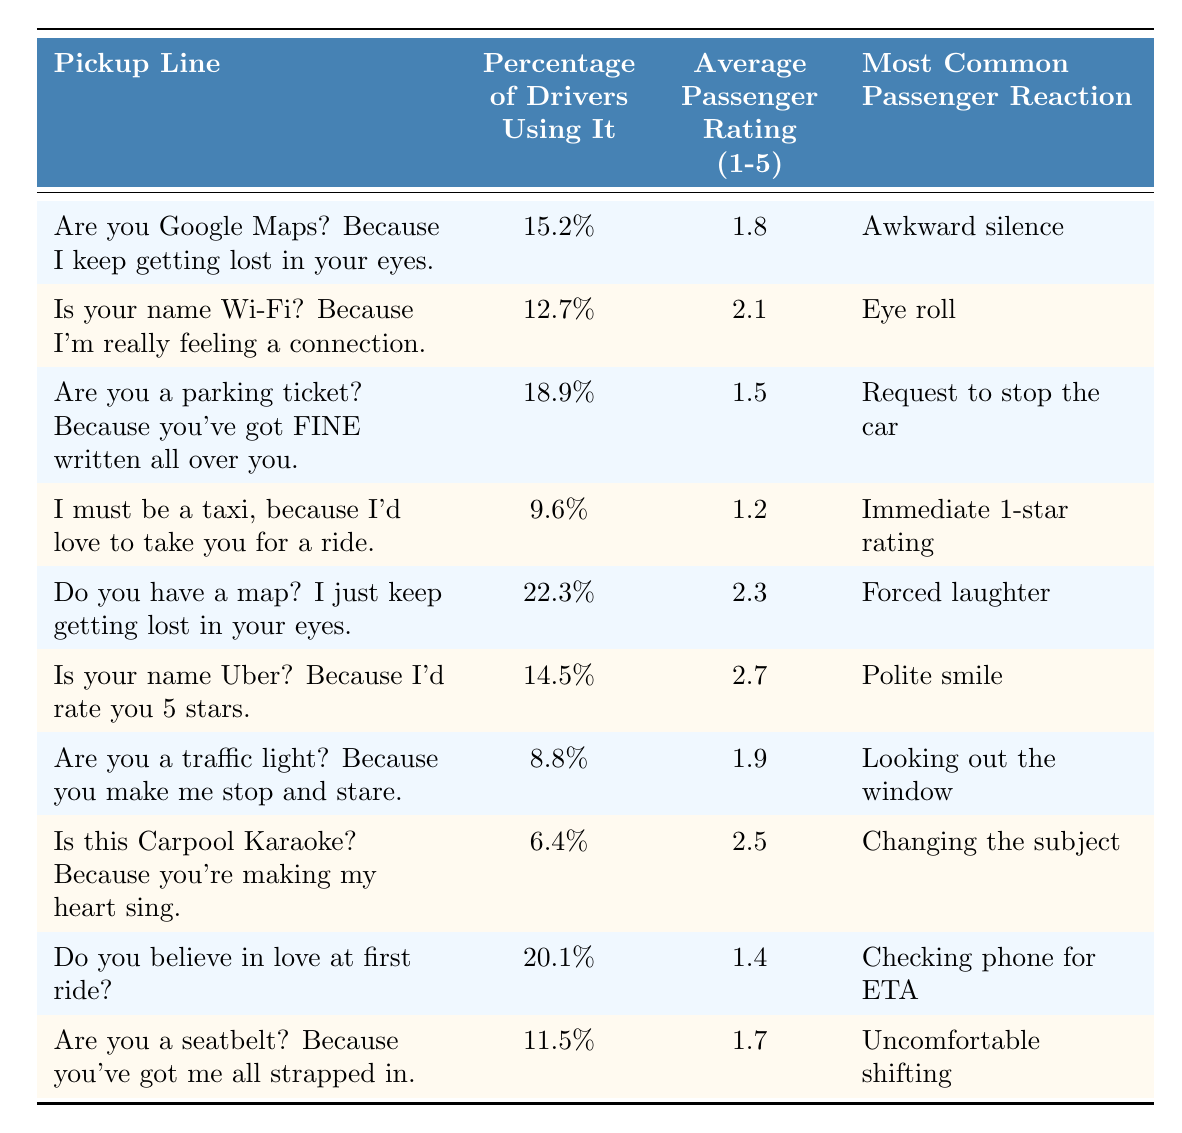What is the pickup line that received the highest average passenger rating? Looking at the "Average Passenger Rating" column, the highest value is 2.7, corresponding to the pickup line "Is your name Uber? Because I'd rate you 5 stars."
Answer: "Is your name Uber? Because I'd rate you 5 stars." Which pickup line has the lowest percentage of drivers using it? By checking the "Percentage of Drivers Using It" column, the lowest value is 6.4%, which is for the pickup line "Is this Carpool Karaoke? Because you're making my heart sing."
Answer: "Is this Carpool Karaoke? Because you're making my heart sing." True or False: More drivers use the pickup line "Do you believe in love at first ride?" than "Are you a parking ticket?" The percentage for "Do you believe in love at first ride?" is 20.1%, while for "Are you a parking ticket?" it is 18.9%. Since 20.1% is greater than 18.9%, the statement is true.
Answer: True What is the average percentage of drivers using the top three most popular pickup lines? The top three pickup lines by percentage are "Do you have a map?" (22.3%), "Do you believe in love at first ride?" (20.1%), and "Are you a parking ticket?" (18.9%). Adding these: 22.3 + 20.1 + 18.9 = 61.3. There are three lines, so the average is 61.3 / 3 = 20.43.
Answer: 20.43 Which pickup line resulted in the most common passenger reaction of "Awkward silence"? By checking the "Most Common Passenger Reaction" column, the pickup line "Are you Google Maps? Because I keep getting lost in your eyes." is listed for this reaction.
Answer: "Are you Google Maps? Because I keep getting lost in your eyes." What is the sum of the average ratings for pickup lines that include the word "ride"? The pickup lines that include "ride" are "I must be a taxi, because I'd love to take you for a ride." (1.2) and "Do you believe in love at first ride?" (1.4). Adding these gives 1.2 + 1.4 = 2.6.
Answer: 2.6 Is there any pickup line that scored a 1-star rating for average passenger ratings? The line "I must be a taxi, because I'd love to take you for a ride." has an average rating of 1.2, which indicates it received a low score. Thus, it's true that a line scored very low.
Answer: True What is the average reaction type among the top five pickup lines by percentage of drivers using them? Calculating the reactions for the top five lines: "Do you have a map?" (Forced laughter), "Do you believe in love at first ride?" (Checking phone for ETA), "Are you a parking ticket?" (Request to stop the car), "Is your name Uber?" (Polite smile), "Are you Google Maps?" (Awkward silence). The reactions are varied and can't be numerically averaged, but a qualitative average gives mixed responses.
Answer: Mixed Which of the pickup lines had an average passenger rating of 1.5? The pickup line "Are you a parking ticket? Because you've got FINE written all over you." has an average rating of 1.5, matching the criterion.
Answer: "Are you a parking ticket? Because you've got FINE written all over you." 